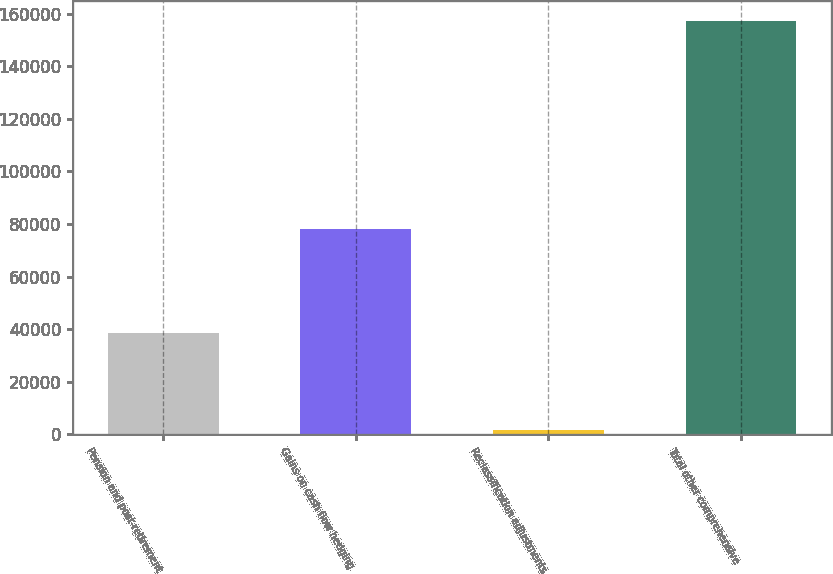Convert chart to OTSL. <chart><loc_0><loc_0><loc_500><loc_500><bar_chart><fcel>Pension and post-retirement<fcel>Gains on cash flow hedging<fcel>Reclassification adjustments<fcel>Total other comprehensive<nl><fcel>38643<fcel>78257<fcel>1862<fcel>157064<nl></chart> 